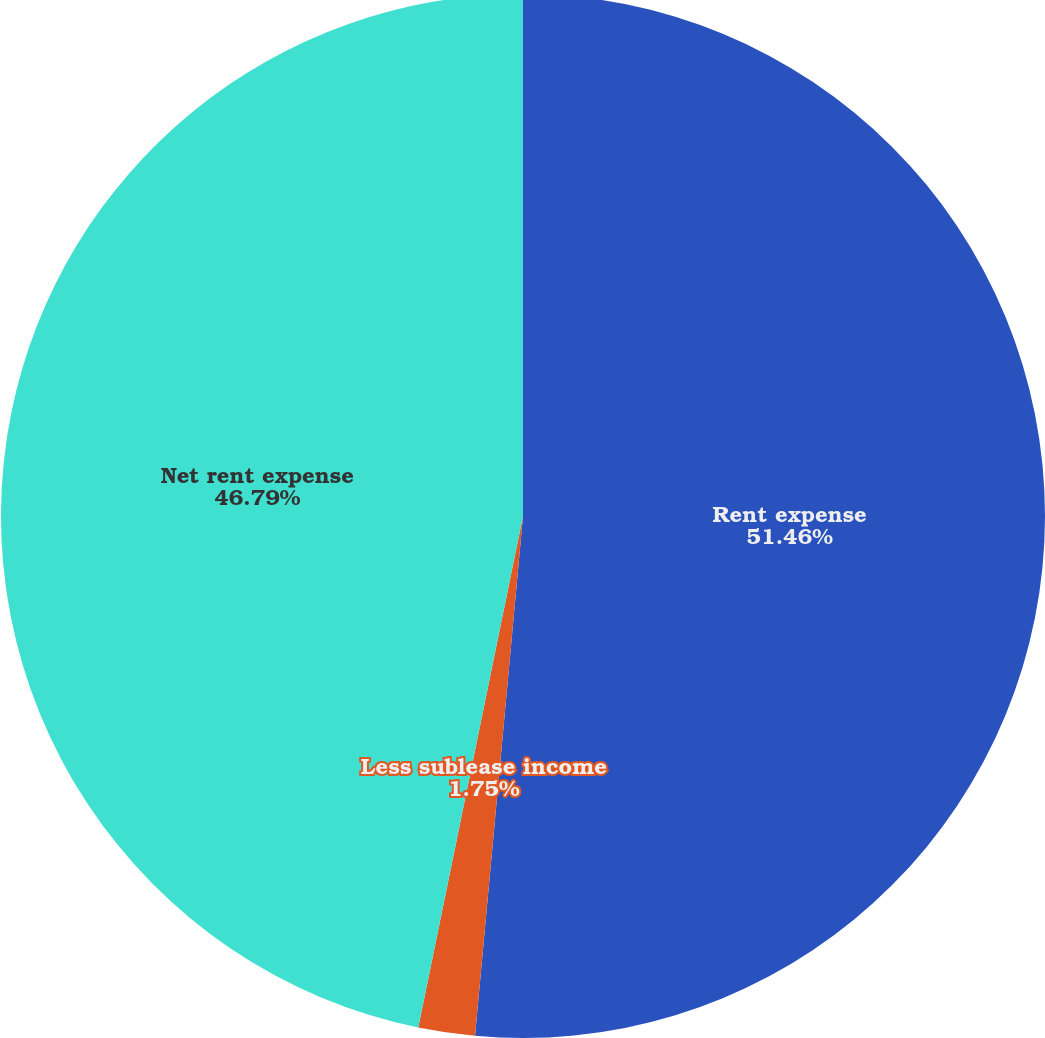Convert chart. <chart><loc_0><loc_0><loc_500><loc_500><pie_chart><fcel>Rent expense<fcel>Less sublease income<fcel>Net rent expense<nl><fcel>51.47%<fcel>1.75%<fcel>46.79%<nl></chart> 